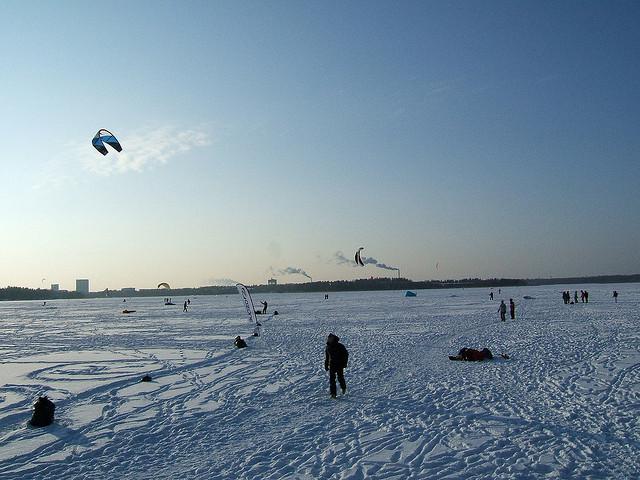Is it cold?
Keep it brief. Yes. What is covering the ground?
Keep it brief. Snow. How many kites are in the air?
Answer briefly. 1. Is this winter?
Answer briefly. Yes. 